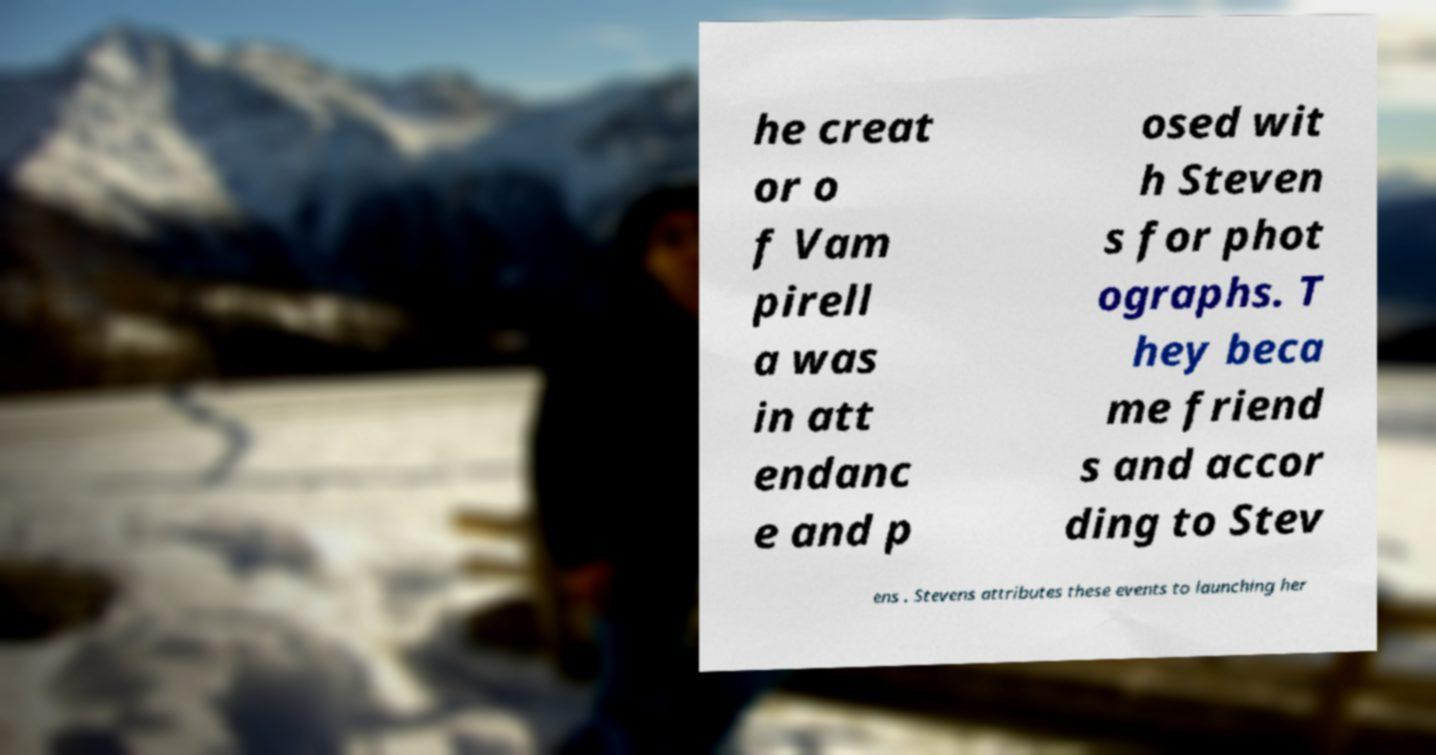Can you read and provide the text displayed in the image?This photo seems to have some interesting text. Can you extract and type it out for me? he creat or o f Vam pirell a was in att endanc e and p osed wit h Steven s for phot ographs. T hey beca me friend s and accor ding to Stev ens . Stevens attributes these events to launching her 